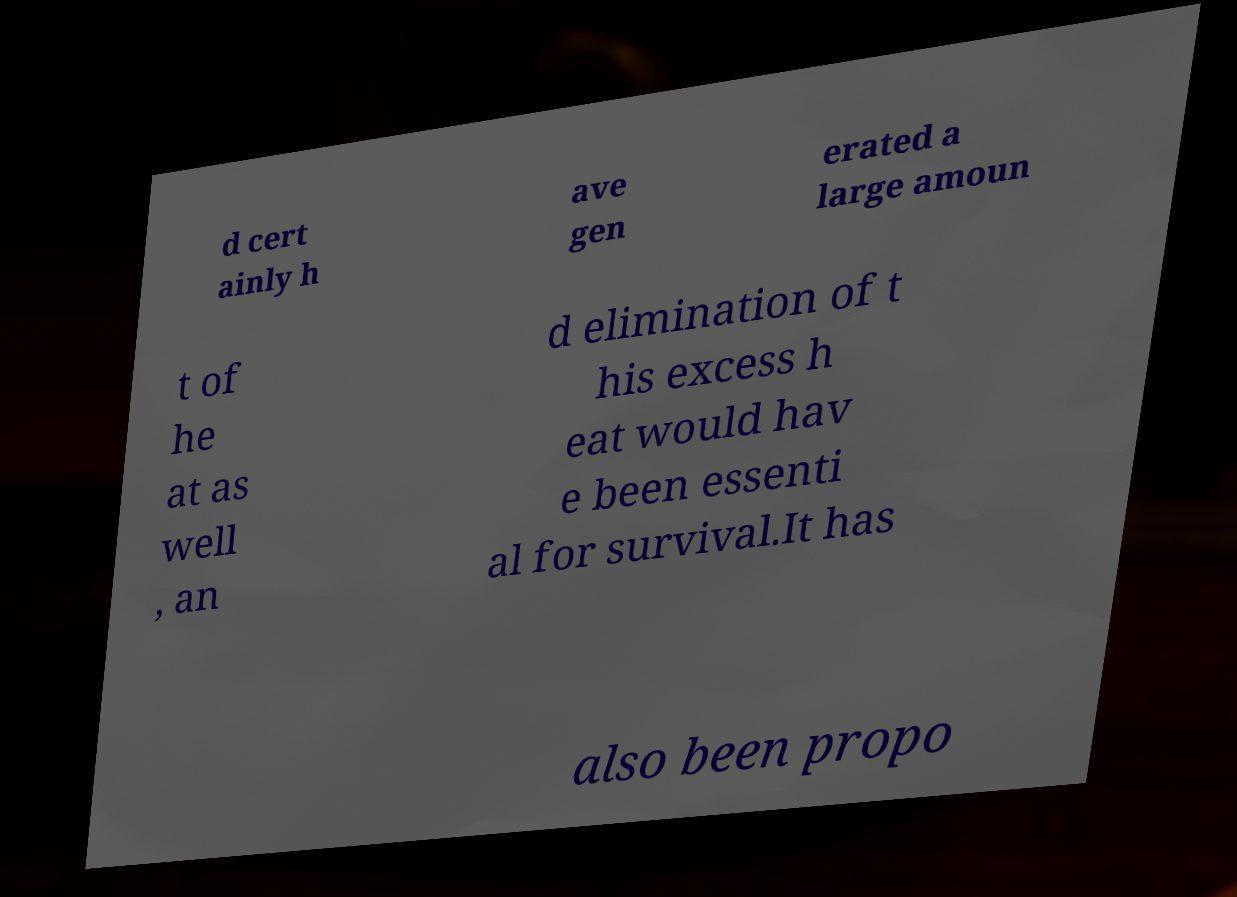Please read and relay the text visible in this image. What does it say? d cert ainly h ave gen erated a large amoun t of he at as well , an d elimination of t his excess h eat would hav e been essenti al for survival.It has also been propo 